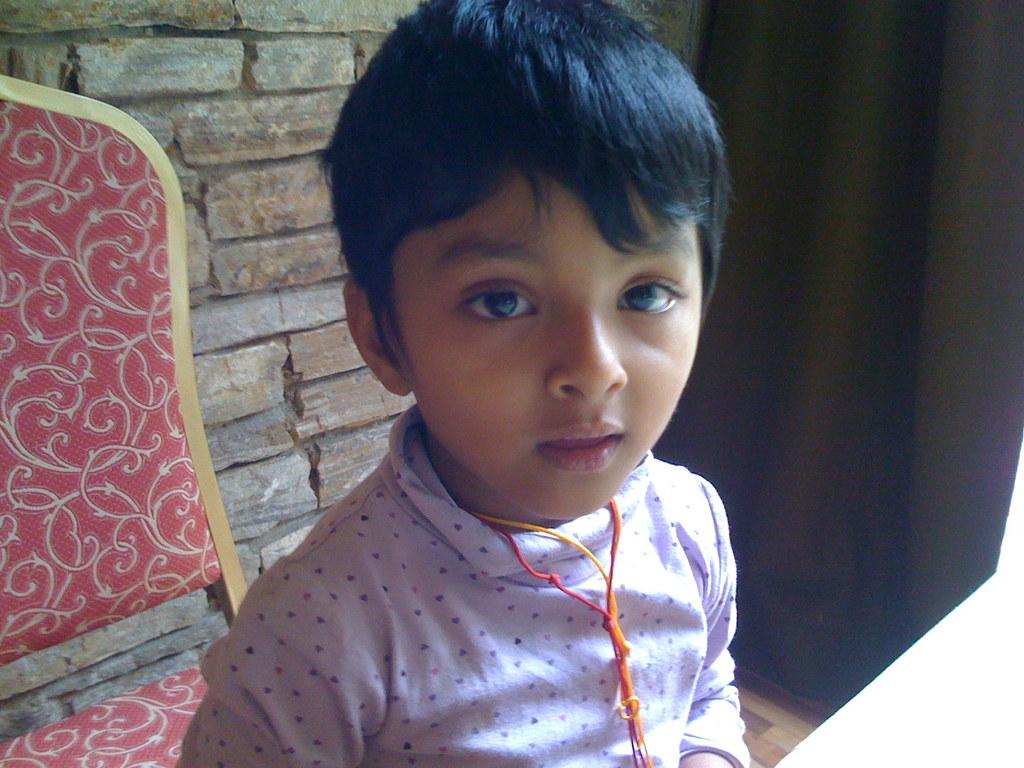What is the main subject in the foreground of the image? There is a boy in the foreground of the image. What can be seen in the background of the image? There is a chair and a wall in the background of the image. What type of window treatment is present in the image? There is a curtain on the right side of the image. What is visible at the bottom of the image? There is a floor visible at the bottom of the image. What type of jar is the boy holding in the image? There is no jar present in the image; the boy is not holding anything. What is the boy's facial expression in the image? The provided facts do not mention the boy's facial expression, so we cannot determine his smile from the information given. 